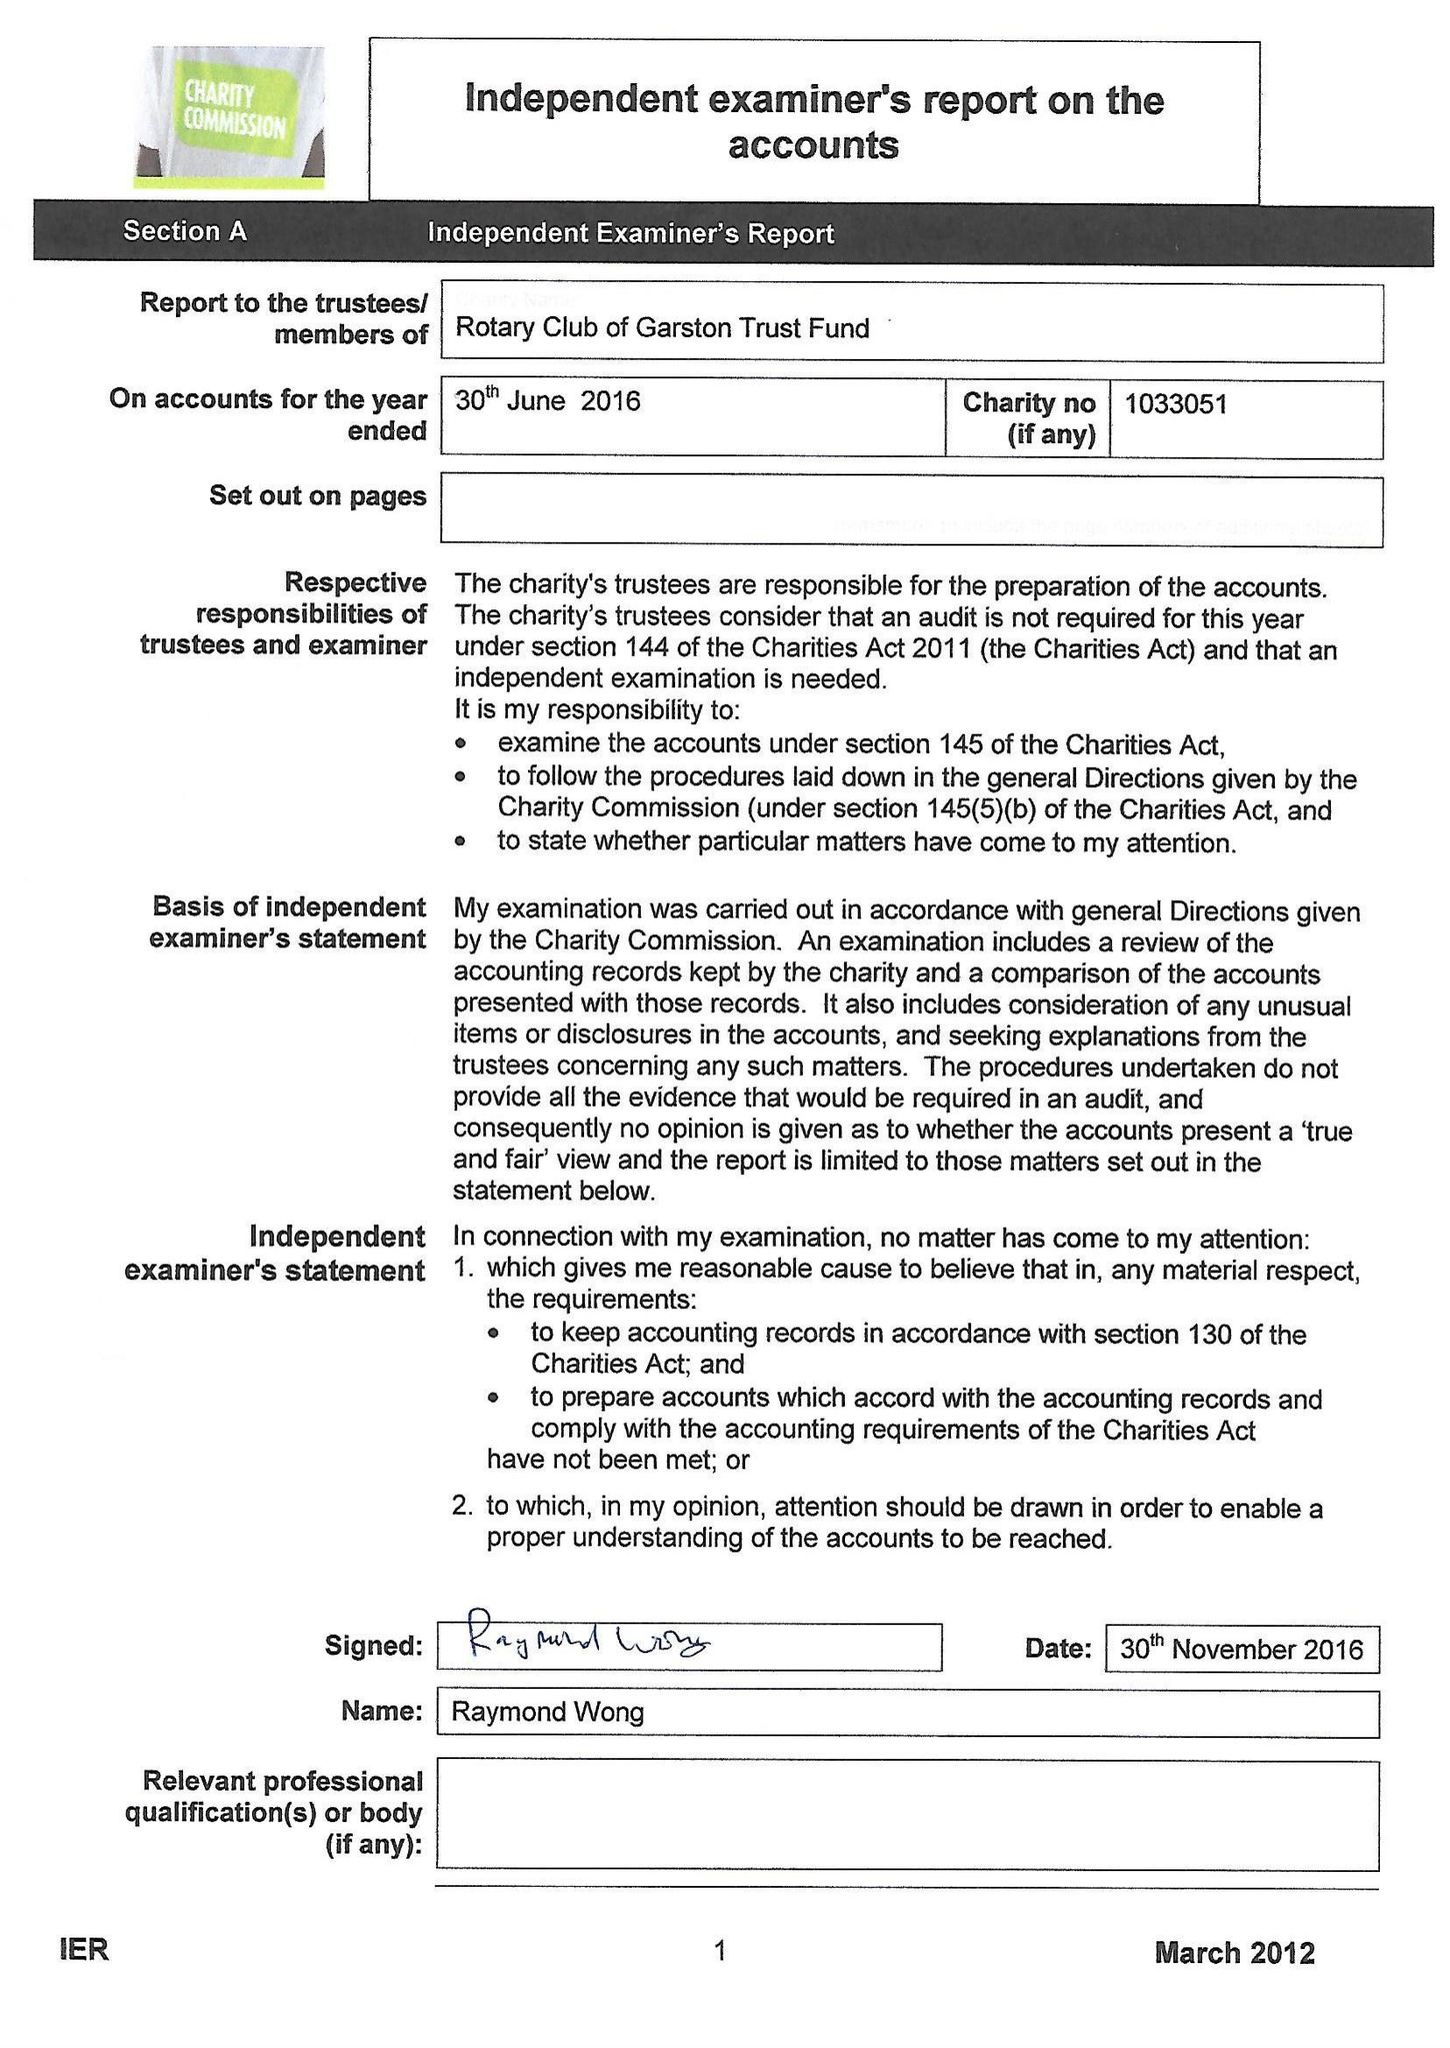What is the value for the address__postcode?
Answer the question using a single word or phrase. L18 6JG 